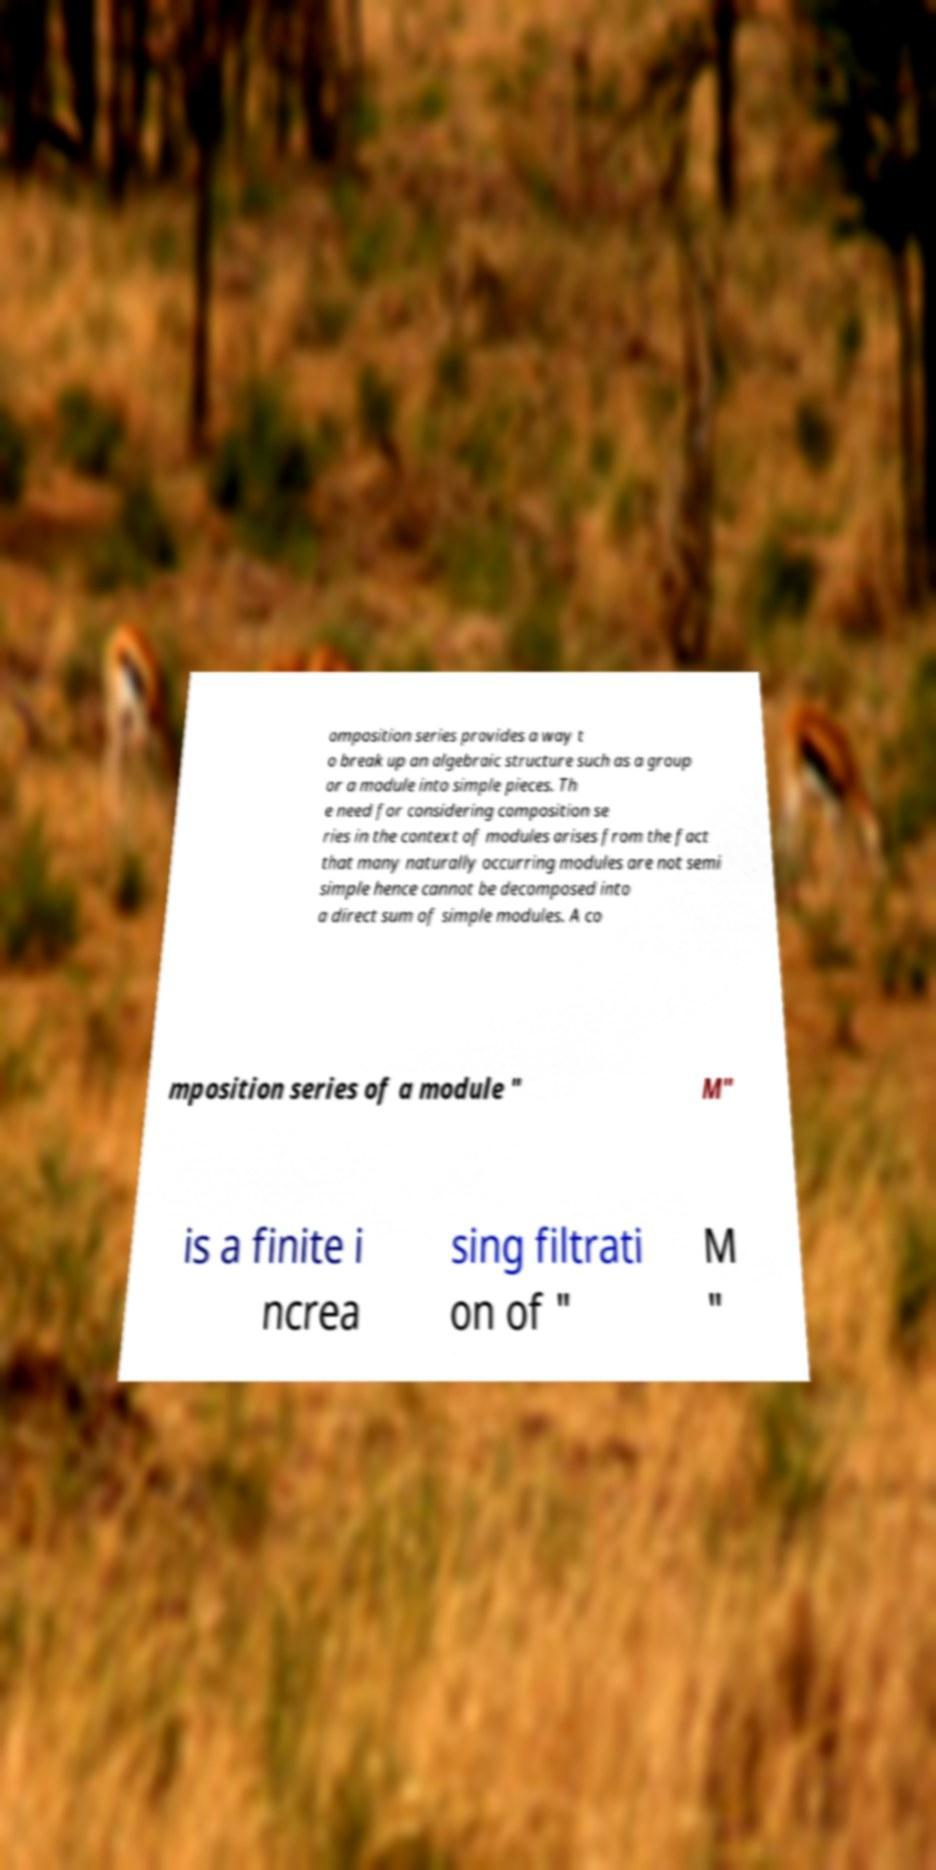For documentation purposes, I need the text within this image transcribed. Could you provide that? omposition series provides a way t o break up an algebraic structure such as a group or a module into simple pieces. Th e need for considering composition se ries in the context of modules arises from the fact that many naturally occurring modules are not semi simple hence cannot be decomposed into a direct sum of simple modules. A co mposition series of a module " M" is a finite i ncrea sing filtrati on of " M " 